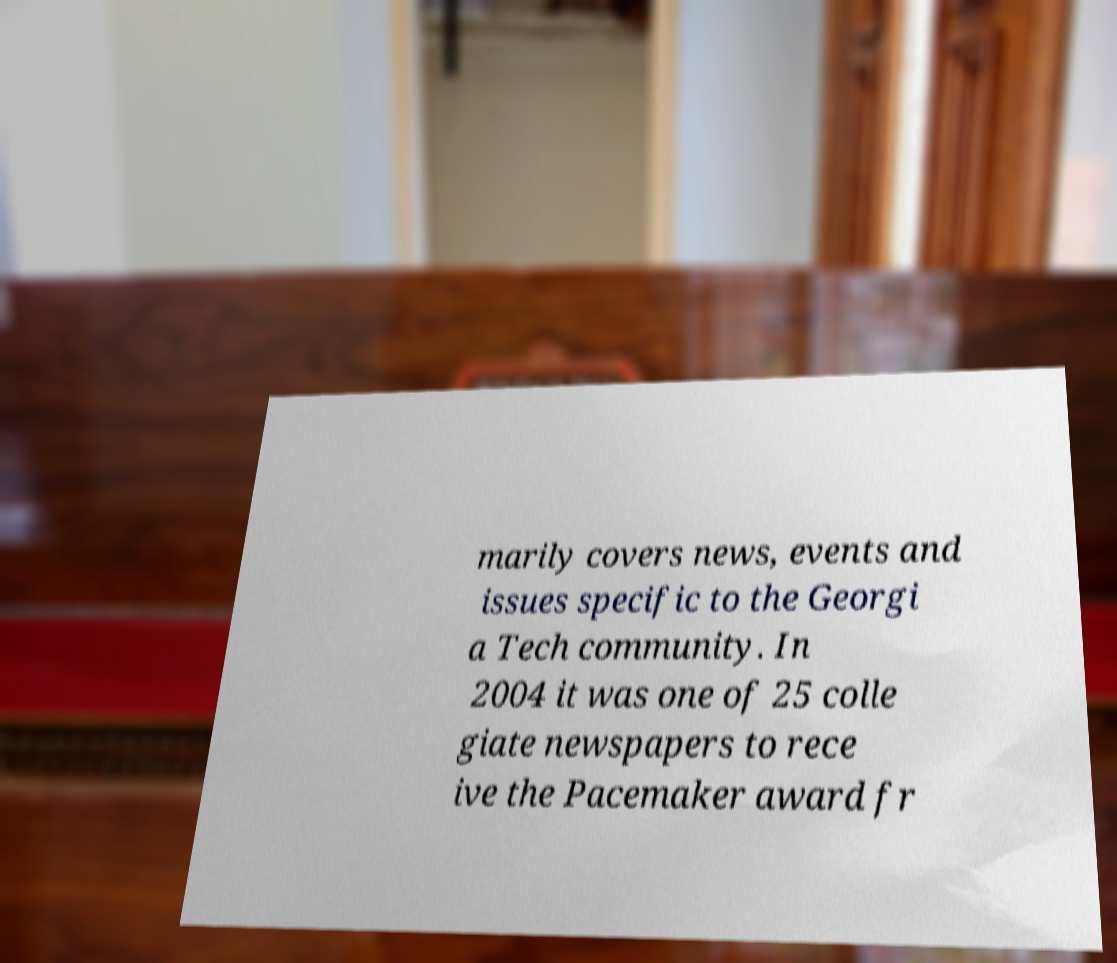There's text embedded in this image that I need extracted. Can you transcribe it verbatim? marily covers news, events and issues specific to the Georgi a Tech community. In 2004 it was one of 25 colle giate newspapers to rece ive the Pacemaker award fr 